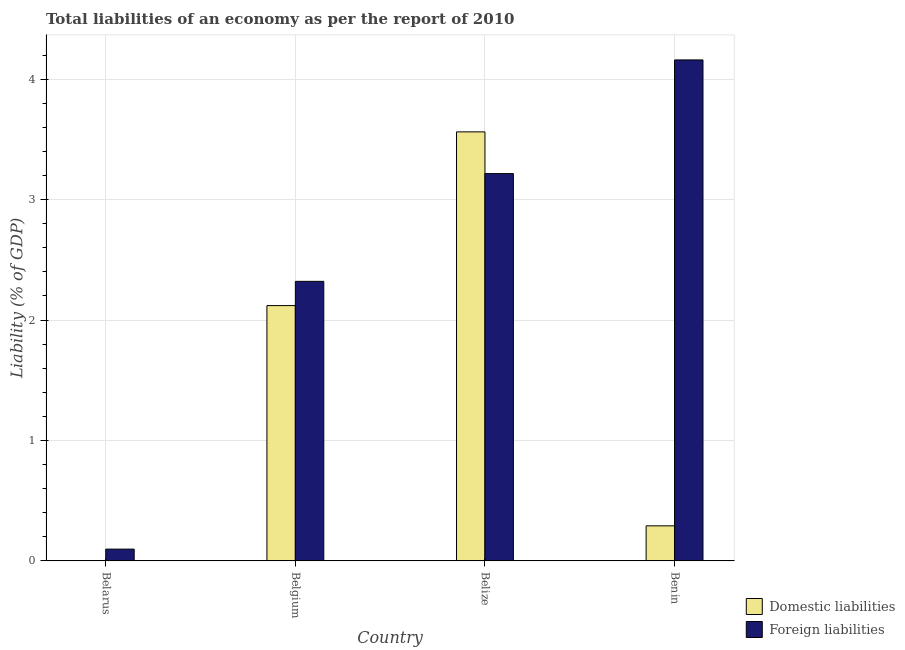How many bars are there on the 2nd tick from the right?
Offer a terse response. 2. What is the label of the 4th group of bars from the left?
Your response must be concise. Benin. What is the incurrence of domestic liabilities in Belize?
Offer a terse response. 3.56. Across all countries, what is the maximum incurrence of domestic liabilities?
Keep it short and to the point. 3.56. Across all countries, what is the minimum incurrence of domestic liabilities?
Provide a short and direct response. 0. In which country was the incurrence of foreign liabilities maximum?
Provide a short and direct response. Benin. What is the total incurrence of foreign liabilities in the graph?
Keep it short and to the point. 9.8. What is the difference between the incurrence of foreign liabilities in Belize and that in Benin?
Make the answer very short. -0.94. What is the difference between the incurrence of foreign liabilities in Benin and the incurrence of domestic liabilities in Belarus?
Make the answer very short. 4.16. What is the average incurrence of domestic liabilities per country?
Keep it short and to the point. 1.49. What is the difference between the incurrence of domestic liabilities and incurrence of foreign liabilities in Belgium?
Make the answer very short. -0.2. In how many countries, is the incurrence of foreign liabilities greater than 2.4 %?
Your answer should be very brief. 2. What is the ratio of the incurrence of domestic liabilities in Belgium to that in Benin?
Keep it short and to the point. 7.28. What is the difference between the highest and the second highest incurrence of domestic liabilities?
Ensure brevity in your answer.  1.44. What is the difference between the highest and the lowest incurrence of domestic liabilities?
Offer a very short reply. 3.56. Is the sum of the incurrence of foreign liabilities in Belarus and Belize greater than the maximum incurrence of domestic liabilities across all countries?
Ensure brevity in your answer.  No. How many bars are there?
Offer a very short reply. 7. Are all the bars in the graph horizontal?
Your response must be concise. No. Are the values on the major ticks of Y-axis written in scientific E-notation?
Ensure brevity in your answer.  No. Does the graph contain grids?
Keep it short and to the point. Yes. Where does the legend appear in the graph?
Ensure brevity in your answer.  Bottom right. What is the title of the graph?
Your answer should be very brief. Total liabilities of an economy as per the report of 2010. Does "Register a business" appear as one of the legend labels in the graph?
Ensure brevity in your answer.  No. What is the label or title of the X-axis?
Your answer should be very brief. Country. What is the label or title of the Y-axis?
Your answer should be very brief. Liability (% of GDP). What is the Liability (% of GDP) of Domestic liabilities in Belarus?
Provide a short and direct response. 0. What is the Liability (% of GDP) of Foreign liabilities in Belarus?
Your response must be concise. 0.1. What is the Liability (% of GDP) of Domestic liabilities in Belgium?
Your answer should be very brief. 2.12. What is the Liability (% of GDP) in Foreign liabilities in Belgium?
Give a very brief answer. 2.32. What is the Liability (% of GDP) in Domestic liabilities in Belize?
Your answer should be very brief. 3.56. What is the Liability (% of GDP) of Foreign liabilities in Belize?
Ensure brevity in your answer.  3.22. What is the Liability (% of GDP) in Domestic liabilities in Benin?
Make the answer very short. 0.29. What is the Liability (% of GDP) in Foreign liabilities in Benin?
Offer a terse response. 4.16. Across all countries, what is the maximum Liability (% of GDP) in Domestic liabilities?
Make the answer very short. 3.56. Across all countries, what is the maximum Liability (% of GDP) in Foreign liabilities?
Offer a terse response. 4.16. Across all countries, what is the minimum Liability (% of GDP) of Domestic liabilities?
Provide a succinct answer. 0. Across all countries, what is the minimum Liability (% of GDP) in Foreign liabilities?
Offer a terse response. 0.1. What is the total Liability (% of GDP) in Domestic liabilities in the graph?
Keep it short and to the point. 5.97. What is the total Liability (% of GDP) in Foreign liabilities in the graph?
Offer a terse response. 9.8. What is the difference between the Liability (% of GDP) of Foreign liabilities in Belarus and that in Belgium?
Keep it short and to the point. -2.22. What is the difference between the Liability (% of GDP) of Foreign liabilities in Belarus and that in Belize?
Offer a terse response. -3.12. What is the difference between the Liability (% of GDP) of Foreign liabilities in Belarus and that in Benin?
Your answer should be compact. -4.06. What is the difference between the Liability (% of GDP) in Domestic liabilities in Belgium and that in Belize?
Offer a terse response. -1.44. What is the difference between the Liability (% of GDP) of Foreign liabilities in Belgium and that in Belize?
Your answer should be very brief. -0.89. What is the difference between the Liability (% of GDP) in Domestic liabilities in Belgium and that in Benin?
Your answer should be compact. 1.83. What is the difference between the Liability (% of GDP) in Foreign liabilities in Belgium and that in Benin?
Provide a short and direct response. -1.84. What is the difference between the Liability (% of GDP) of Domestic liabilities in Belize and that in Benin?
Your response must be concise. 3.27. What is the difference between the Liability (% of GDP) in Foreign liabilities in Belize and that in Benin?
Your response must be concise. -0.94. What is the difference between the Liability (% of GDP) in Domestic liabilities in Belgium and the Liability (% of GDP) in Foreign liabilities in Belize?
Offer a very short reply. -1.1. What is the difference between the Liability (% of GDP) in Domestic liabilities in Belgium and the Liability (% of GDP) in Foreign liabilities in Benin?
Provide a succinct answer. -2.04. What is the difference between the Liability (% of GDP) of Domestic liabilities in Belize and the Liability (% of GDP) of Foreign liabilities in Benin?
Provide a short and direct response. -0.6. What is the average Liability (% of GDP) in Domestic liabilities per country?
Your answer should be compact. 1.49. What is the average Liability (% of GDP) of Foreign liabilities per country?
Give a very brief answer. 2.45. What is the difference between the Liability (% of GDP) in Domestic liabilities and Liability (% of GDP) in Foreign liabilities in Belgium?
Your response must be concise. -0.2. What is the difference between the Liability (% of GDP) in Domestic liabilities and Liability (% of GDP) in Foreign liabilities in Belize?
Provide a short and direct response. 0.35. What is the difference between the Liability (% of GDP) in Domestic liabilities and Liability (% of GDP) in Foreign liabilities in Benin?
Your answer should be compact. -3.87. What is the ratio of the Liability (% of GDP) in Foreign liabilities in Belarus to that in Belgium?
Offer a very short reply. 0.04. What is the ratio of the Liability (% of GDP) in Foreign liabilities in Belarus to that in Belize?
Provide a succinct answer. 0.03. What is the ratio of the Liability (% of GDP) in Foreign liabilities in Belarus to that in Benin?
Provide a short and direct response. 0.02. What is the ratio of the Liability (% of GDP) of Domestic liabilities in Belgium to that in Belize?
Ensure brevity in your answer.  0.6. What is the ratio of the Liability (% of GDP) in Foreign liabilities in Belgium to that in Belize?
Your answer should be compact. 0.72. What is the ratio of the Liability (% of GDP) of Domestic liabilities in Belgium to that in Benin?
Your answer should be very brief. 7.28. What is the ratio of the Liability (% of GDP) of Foreign liabilities in Belgium to that in Benin?
Give a very brief answer. 0.56. What is the ratio of the Liability (% of GDP) in Domestic liabilities in Belize to that in Benin?
Offer a terse response. 12.24. What is the ratio of the Liability (% of GDP) in Foreign liabilities in Belize to that in Benin?
Provide a short and direct response. 0.77. What is the difference between the highest and the second highest Liability (% of GDP) in Domestic liabilities?
Ensure brevity in your answer.  1.44. What is the difference between the highest and the second highest Liability (% of GDP) of Foreign liabilities?
Make the answer very short. 0.94. What is the difference between the highest and the lowest Liability (% of GDP) of Domestic liabilities?
Your answer should be very brief. 3.56. What is the difference between the highest and the lowest Liability (% of GDP) of Foreign liabilities?
Make the answer very short. 4.06. 